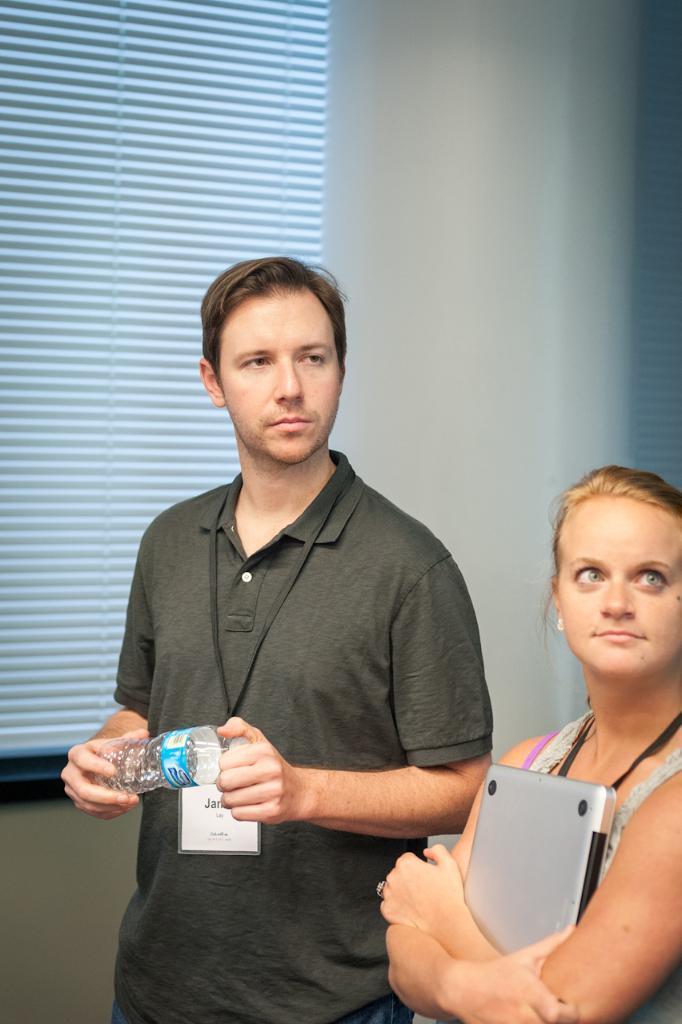Describe this image in one or two sentences. In the image we can see there are two people, right side is a woman and left side is a man. Man is holding a bottle in his hand and woman is holding a laptop. 